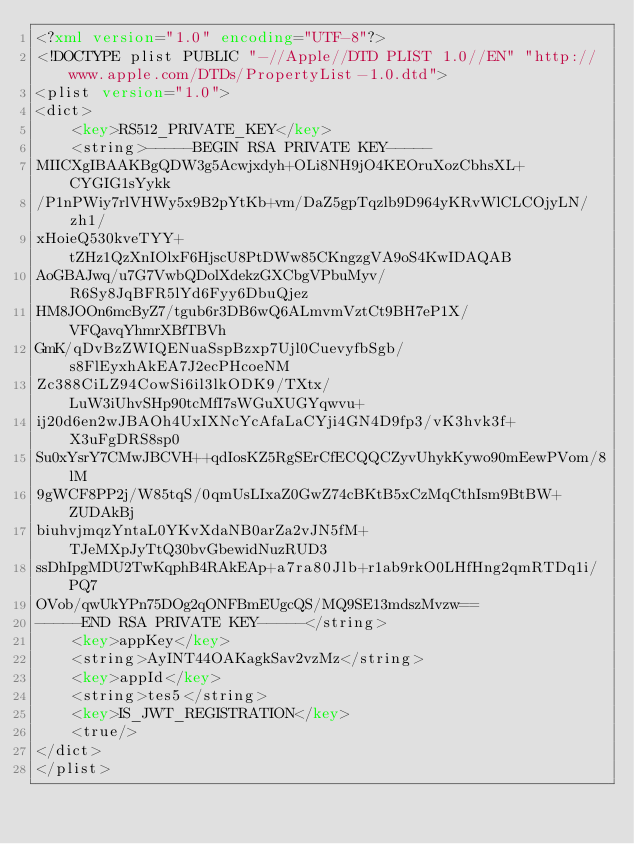Convert code to text. <code><loc_0><loc_0><loc_500><loc_500><_XML_><?xml version="1.0" encoding="UTF-8"?>
<!DOCTYPE plist PUBLIC "-//Apple//DTD PLIST 1.0//EN" "http://www.apple.com/DTDs/PropertyList-1.0.dtd">
<plist version="1.0">
<dict>
	<key>RS512_PRIVATE_KEY</key>
	<string>-----BEGIN RSA PRIVATE KEY-----
MIICXgIBAAKBgQDW3g5Acwjxdyh+OLi8NH9jO4KEOruXozCbhsXL+CYGIG1sYykk
/P1nPWiy7rlVHWy5x9B2pYtKb+vm/DaZ5gpTqzlb9D964yKRvWlCLCOjyLN/zh1/
xHoieQ530kveTYY+tZHz1QzXnIOlxF6HjscU8PtDWw85CKngzgVA9oS4KwIDAQAB
AoGBAJwq/u7G7VwbQDolXdekzGXCbgVPbuMyv/R6Sy8JqBFR5lYd6Fyy6DbuQjez
HM8JOOn6mcByZ7/tgub6r3DB6wQ6ALmvmVztCt9BH7eP1X/VFQavqYhmrXBfTBVh
GmK/qDvBzZWIQENuaSspBzxp7Ujl0CuevyfbSgb/s8FlEyxhAkEA7J2ecPHcoeNM
Zc388CiLZ94CowSi6il3lkODK9/TXtx/LuW3iUhvSHp90tcMfI7sWGuXUGYqwvu+
ij20d6en2wJBAOh4UxIXNcYcAfaLaCYji4GN4D9fp3/vK3hvk3f+X3uFgDRS8sp0
Su0xYsrY7CMwJBCVH++qdIosKZ5RgSErCfECQQCZyvUhykKywo90mEewPVom/8lM
9gWCF8PP2j/W85tqS/0qmUsLIxaZ0GwZ74cBKtB5xCzMqCthIsm9BtBW+ZUDAkBj
biuhvjmqzYntaL0YKvXdaNB0arZa2vJN5fM+TJeMXpJyTtQ30bvGbewidNuzRUD3
ssDhIpgMDU2TwKqphB4RAkEAp+a7ra80Jlb+r1ab9rkO0LHfHng2qmRTDq1i/PQ7
OVob/qwUkYPn75DOg2qONFBmEUgcQS/MQ9SE13mdszMvzw==
-----END RSA PRIVATE KEY-----</string>
	<key>appKey</key>
	<string>AyINT44OAKagkSav2vzMz</string>
	<key>appId</key>
	<string>tes5</string>
	<key>IS_JWT_REGISTRATION</key>
	<true/>
</dict>
</plist>
</code> 